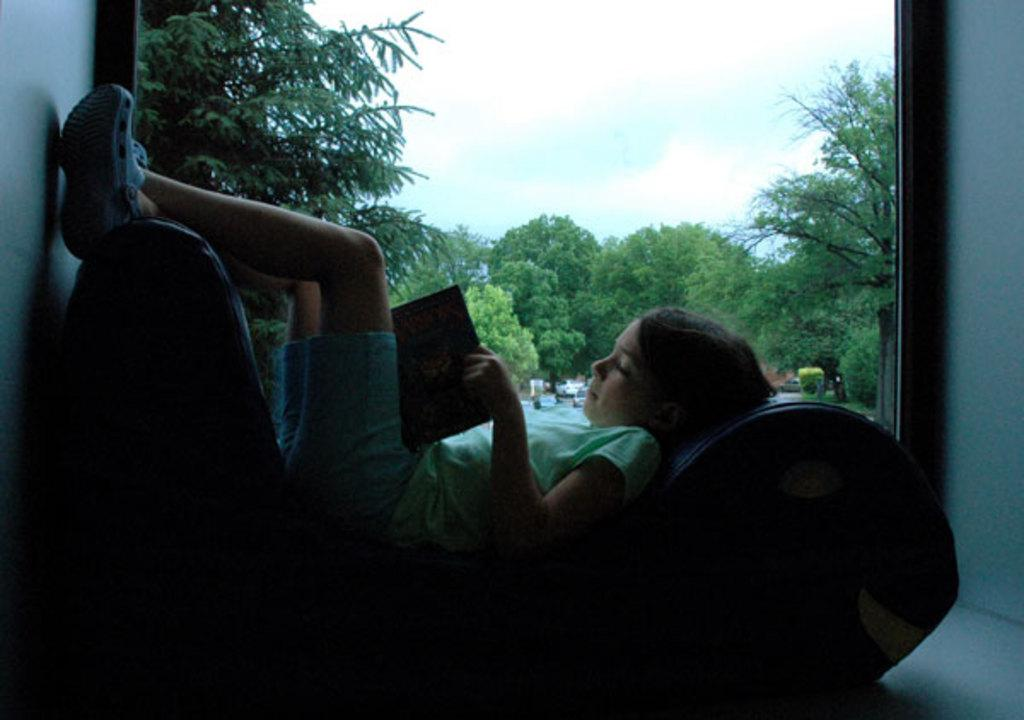Who is the main subject in the image? There is a girl in the image. What is the girl doing in the image? The girl is lying on a couch. What is the girl holding in her hand? The girl is holding a book in her hand. What can be seen through the glass window in the image? Trees and the sky are visible through the glass window. What type of vest is the girl wearing in the image? There is no vest visible in the image; the girl is wearing a dress or a skirt. What is the girl's father doing in the image? There is no father present in the image; it only features the girl. 